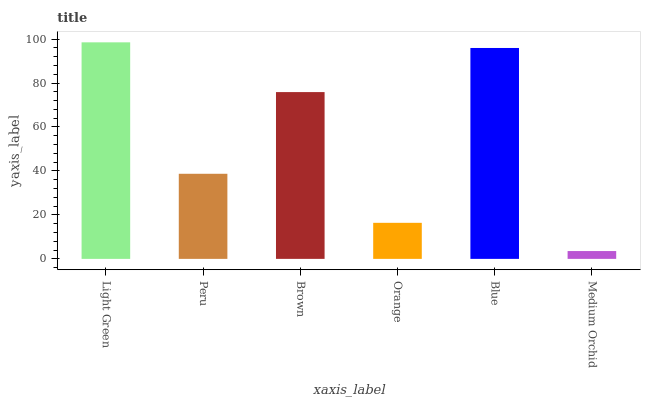Is Peru the minimum?
Answer yes or no. No. Is Peru the maximum?
Answer yes or no. No. Is Light Green greater than Peru?
Answer yes or no. Yes. Is Peru less than Light Green?
Answer yes or no. Yes. Is Peru greater than Light Green?
Answer yes or no. No. Is Light Green less than Peru?
Answer yes or no. No. Is Brown the high median?
Answer yes or no. Yes. Is Peru the low median?
Answer yes or no. Yes. Is Light Green the high median?
Answer yes or no. No. Is Light Green the low median?
Answer yes or no. No. 